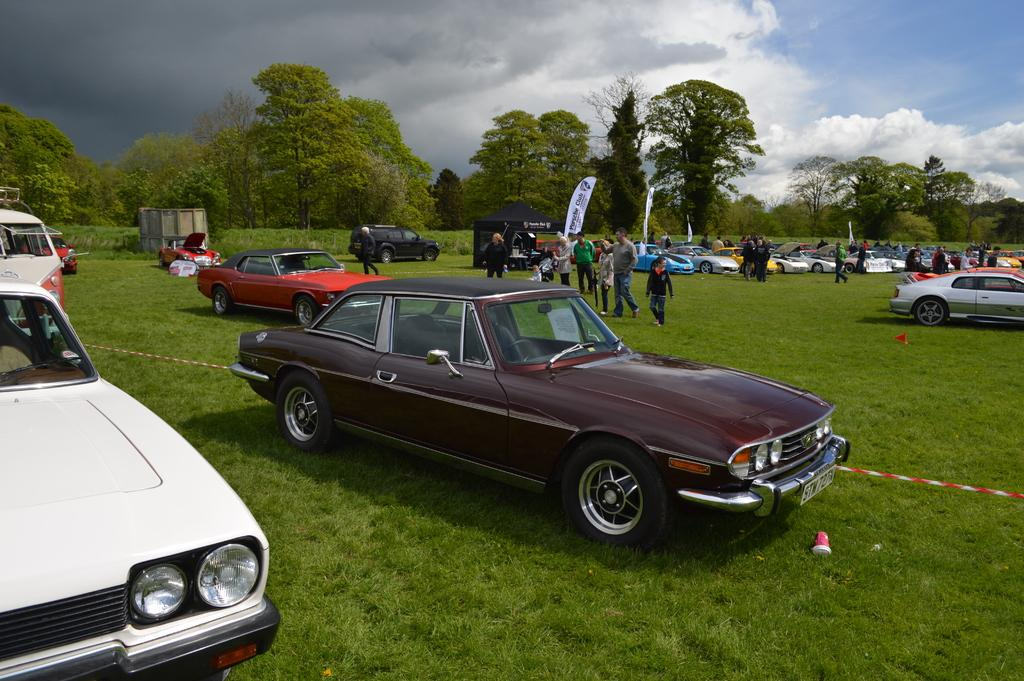How many people can be seen in the image? There are people in the image, but the exact number is not specified. What can be seen beside the people in the image? Cars are parked aside in the image. What is the flag associated with? There is a flag in the image, but its purpose or association is not mentioned. What is set up on the grass in the image? There is a tent on the grass in the image. What type of natural environment is visible in the background of the image? Trees and plants are visible in the background of the image. What is visible in the sky in the image? The sky is visible in the background of the image, and it appears cloudy. How many legs does the farm have in the image? There is no farm present in the image, so it is not possible to determine the number of legs it might have. 